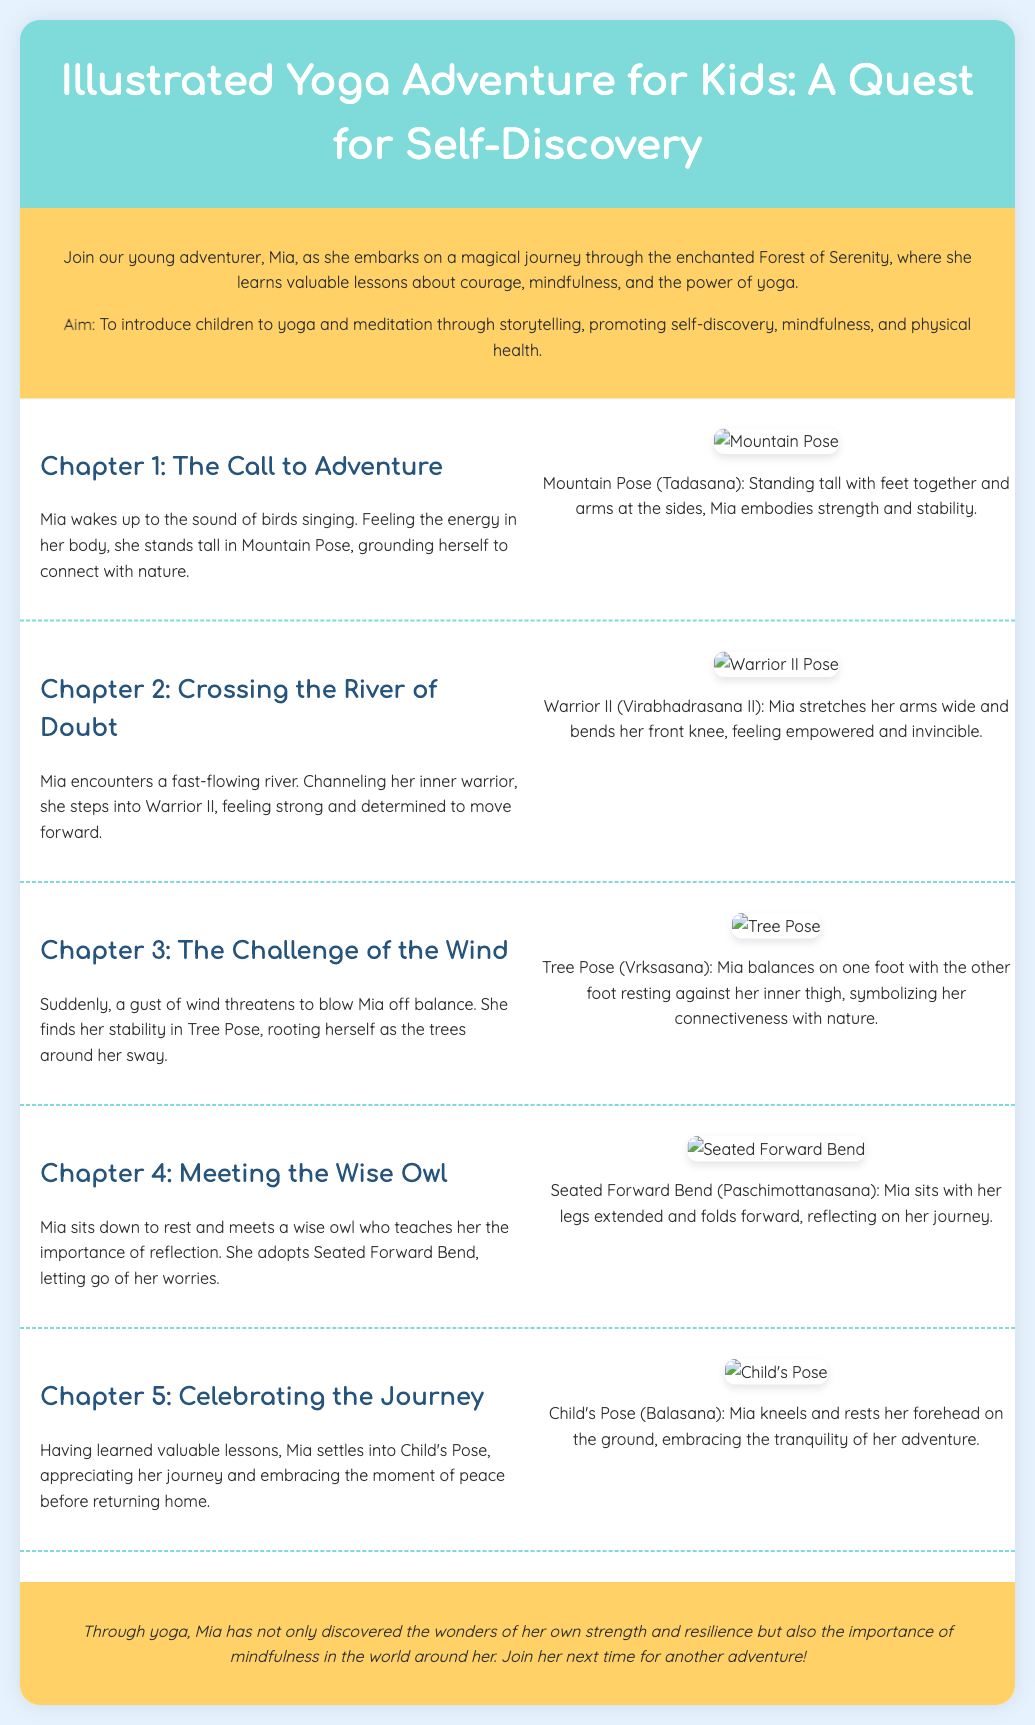What is the name of the young adventurer? The document introduces Mia as the main character who embarks on an adventure.
Answer: Mia What pose does Mia start with in Chapter 1? In Chapter 1, Mia begins her adventure by standing in Mountain Pose.
Answer: Mountain Pose How many chapters are in the document? The document contains five chapters focused on Mia's journey.
Answer: Five What lesson does Mia learn from the wise owl? The wise owl teaches Mia about the importance of reflection in her journey.
Answer: Reflection What yoga pose does Mia adopt when she meets the wise owl? Mia adopts Seated Forward Bend while reflecting on her journey with the wise owl.
Answer: Seated Forward Bend What color is the background of the header? The header has a background color of #7FDBDA, a shade of teal.
Answer: Teal What is the aim of the journey described in the document? The aim is to introduce children to yoga and meditation through storytelling.
Answer: Introduce children to yoga and meditation What pose does Mia settle into at the end of her journey? At the end of her journey, Mia settles into Child's Pose.
Answer: Child's Pose What mythical location does Mia journey through? Mia embarks on her journey through the enchanted Forest of Serenity.
Answer: Forest of Serenity 